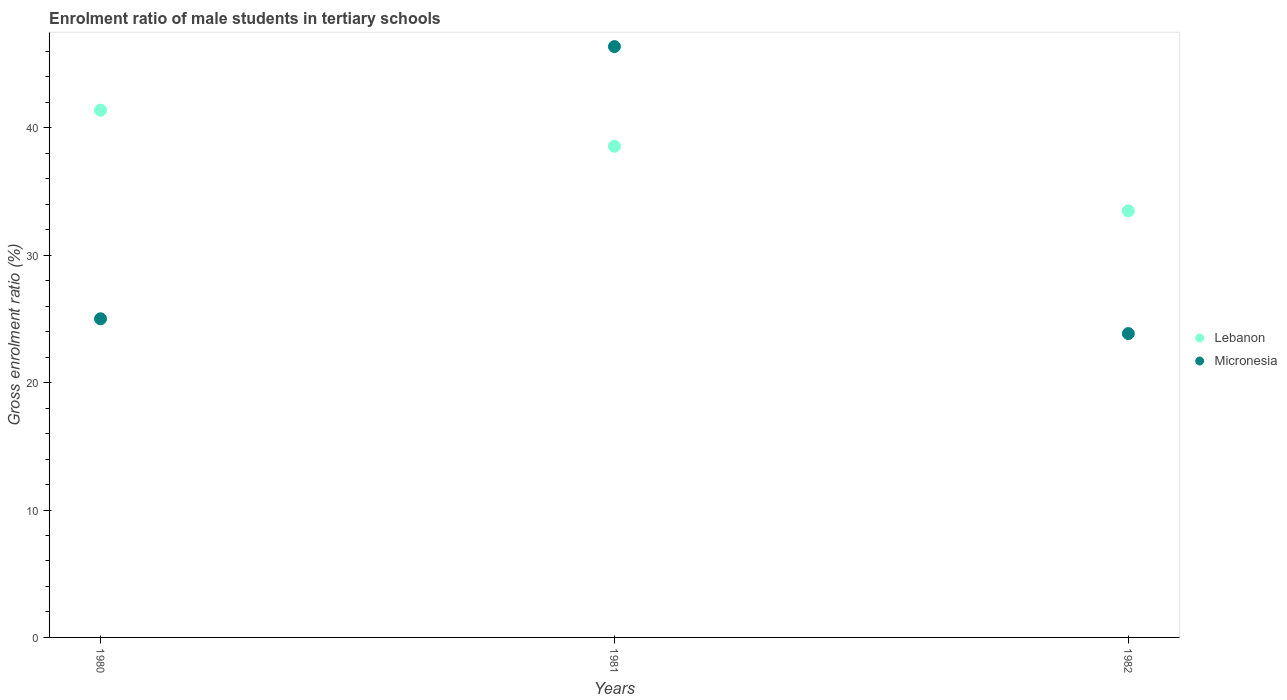Is the number of dotlines equal to the number of legend labels?
Provide a short and direct response. Yes. What is the enrolment ratio of male students in tertiary schools in Micronesia in 1981?
Your answer should be compact. 46.38. Across all years, what is the maximum enrolment ratio of male students in tertiary schools in Lebanon?
Keep it short and to the point. 41.39. Across all years, what is the minimum enrolment ratio of male students in tertiary schools in Micronesia?
Provide a short and direct response. 23.85. In which year was the enrolment ratio of male students in tertiary schools in Micronesia minimum?
Provide a succinct answer. 1982. What is the total enrolment ratio of male students in tertiary schools in Lebanon in the graph?
Offer a very short reply. 113.44. What is the difference between the enrolment ratio of male students in tertiary schools in Lebanon in 1980 and that in 1982?
Ensure brevity in your answer.  7.9. What is the difference between the enrolment ratio of male students in tertiary schools in Micronesia in 1980 and the enrolment ratio of male students in tertiary schools in Lebanon in 1982?
Give a very brief answer. -8.47. What is the average enrolment ratio of male students in tertiary schools in Micronesia per year?
Offer a very short reply. 31.75. In the year 1980, what is the difference between the enrolment ratio of male students in tertiary schools in Lebanon and enrolment ratio of male students in tertiary schools in Micronesia?
Offer a very short reply. 16.38. What is the ratio of the enrolment ratio of male students in tertiary schools in Micronesia in 1981 to that in 1982?
Keep it short and to the point. 1.94. Is the enrolment ratio of male students in tertiary schools in Micronesia in 1981 less than that in 1982?
Offer a terse response. No. What is the difference between the highest and the second highest enrolment ratio of male students in tertiary schools in Lebanon?
Provide a short and direct response. 2.83. What is the difference between the highest and the lowest enrolment ratio of male students in tertiary schools in Micronesia?
Ensure brevity in your answer.  22.53. In how many years, is the enrolment ratio of male students in tertiary schools in Lebanon greater than the average enrolment ratio of male students in tertiary schools in Lebanon taken over all years?
Provide a short and direct response. 2. Does the enrolment ratio of male students in tertiary schools in Micronesia monotonically increase over the years?
Your response must be concise. No. Is the enrolment ratio of male students in tertiary schools in Micronesia strictly greater than the enrolment ratio of male students in tertiary schools in Lebanon over the years?
Your response must be concise. No. Is the enrolment ratio of male students in tertiary schools in Micronesia strictly less than the enrolment ratio of male students in tertiary schools in Lebanon over the years?
Offer a terse response. No. How many dotlines are there?
Make the answer very short. 2. How many years are there in the graph?
Give a very brief answer. 3. What is the difference between two consecutive major ticks on the Y-axis?
Keep it short and to the point. 10. Does the graph contain grids?
Your response must be concise. No. How are the legend labels stacked?
Your answer should be very brief. Vertical. What is the title of the graph?
Keep it short and to the point. Enrolment ratio of male students in tertiary schools. Does "Upper middle income" appear as one of the legend labels in the graph?
Ensure brevity in your answer.  No. What is the Gross enrolment ratio (%) of Lebanon in 1980?
Offer a very short reply. 41.39. What is the Gross enrolment ratio (%) in Micronesia in 1980?
Your answer should be very brief. 25.01. What is the Gross enrolment ratio (%) of Lebanon in 1981?
Your answer should be very brief. 38.56. What is the Gross enrolment ratio (%) of Micronesia in 1981?
Your answer should be compact. 46.38. What is the Gross enrolment ratio (%) of Lebanon in 1982?
Offer a very short reply. 33.49. What is the Gross enrolment ratio (%) in Micronesia in 1982?
Offer a terse response. 23.85. Across all years, what is the maximum Gross enrolment ratio (%) in Lebanon?
Your response must be concise. 41.39. Across all years, what is the maximum Gross enrolment ratio (%) in Micronesia?
Offer a very short reply. 46.38. Across all years, what is the minimum Gross enrolment ratio (%) in Lebanon?
Ensure brevity in your answer.  33.49. Across all years, what is the minimum Gross enrolment ratio (%) in Micronesia?
Give a very brief answer. 23.85. What is the total Gross enrolment ratio (%) in Lebanon in the graph?
Keep it short and to the point. 113.44. What is the total Gross enrolment ratio (%) of Micronesia in the graph?
Keep it short and to the point. 95.25. What is the difference between the Gross enrolment ratio (%) of Lebanon in 1980 and that in 1981?
Provide a succinct answer. 2.83. What is the difference between the Gross enrolment ratio (%) of Micronesia in 1980 and that in 1981?
Provide a short and direct response. -21.37. What is the difference between the Gross enrolment ratio (%) in Lebanon in 1980 and that in 1982?
Offer a terse response. 7.9. What is the difference between the Gross enrolment ratio (%) of Micronesia in 1980 and that in 1982?
Give a very brief answer. 1.16. What is the difference between the Gross enrolment ratio (%) of Lebanon in 1981 and that in 1982?
Provide a succinct answer. 5.07. What is the difference between the Gross enrolment ratio (%) in Micronesia in 1981 and that in 1982?
Give a very brief answer. 22.53. What is the difference between the Gross enrolment ratio (%) in Lebanon in 1980 and the Gross enrolment ratio (%) in Micronesia in 1981?
Offer a very short reply. -4.99. What is the difference between the Gross enrolment ratio (%) in Lebanon in 1980 and the Gross enrolment ratio (%) in Micronesia in 1982?
Keep it short and to the point. 17.54. What is the difference between the Gross enrolment ratio (%) in Lebanon in 1981 and the Gross enrolment ratio (%) in Micronesia in 1982?
Offer a very short reply. 14.7. What is the average Gross enrolment ratio (%) in Lebanon per year?
Your answer should be very brief. 37.81. What is the average Gross enrolment ratio (%) in Micronesia per year?
Offer a terse response. 31.75. In the year 1980, what is the difference between the Gross enrolment ratio (%) of Lebanon and Gross enrolment ratio (%) of Micronesia?
Make the answer very short. 16.38. In the year 1981, what is the difference between the Gross enrolment ratio (%) of Lebanon and Gross enrolment ratio (%) of Micronesia?
Provide a short and direct response. -7.82. In the year 1982, what is the difference between the Gross enrolment ratio (%) of Lebanon and Gross enrolment ratio (%) of Micronesia?
Keep it short and to the point. 9.63. What is the ratio of the Gross enrolment ratio (%) of Lebanon in 1980 to that in 1981?
Provide a short and direct response. 1.07. What is the ratio of the Gross enrolment ratio (%) of Micronesia in 1980 to that in 1981?
Give a very brief answer. 0.54. What is the ratio of the Gross enrolment ratio (%) of Lebanon in 1980 to that in 1982?
Provide a succinct answer. 1.24. What is the ratio of the Gross enrolment ratio (%) in Micronesia in 1980 to that in 1982?
Offer a very short reply. 1.05. What is the ratio of the Gross enrolment ratio (%) in Lebanon in 1981 to that in 1982?
Ensure brevity in your answer.  1.15. What is the ratio of the Gross enrolment ratio (%) in Micronesia in 1981 to that in 1982?
Offer a very short reply. 1.94. What is the difference between the highest and the second highest Gross enrolment ratio (%) of Lebanon?
Provide a succinct answer. 2.83. What is the difference between the highest and the second highest Gross enrolment ratio (%) in Micronesia?
Ensure brevity in your answer.  21.37. What is the difference between the highest and the lowest Gross enrolment ratio (%) in Lebanon?
Your response must be concise. 7.9. What is the difference between the highest and the lowest Gross enrolment ratio (%) in Micronesia?
Offer a terse response. 22.53. 